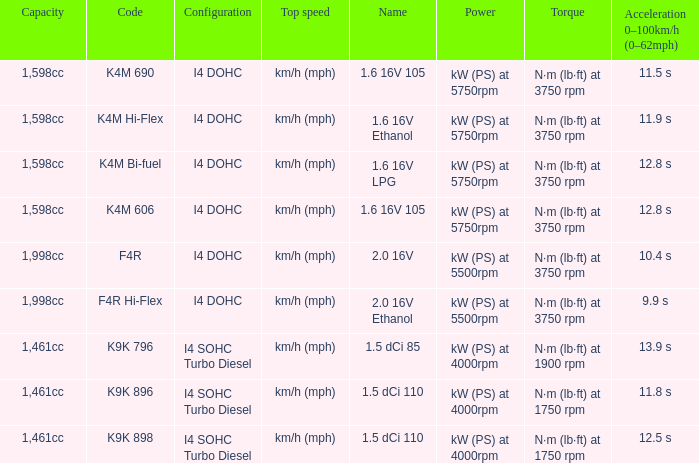What is the code of 1.5 dci 110, which has a capacity of 1,461cc? K9K 896, K9K 898. 